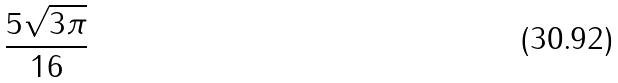Convert formula to latex. <formula><loc_0><loc_0><loc_500><loc_500>\frac { 5 \sqrt { 3 \pi } } { 1 6 }</formula> 